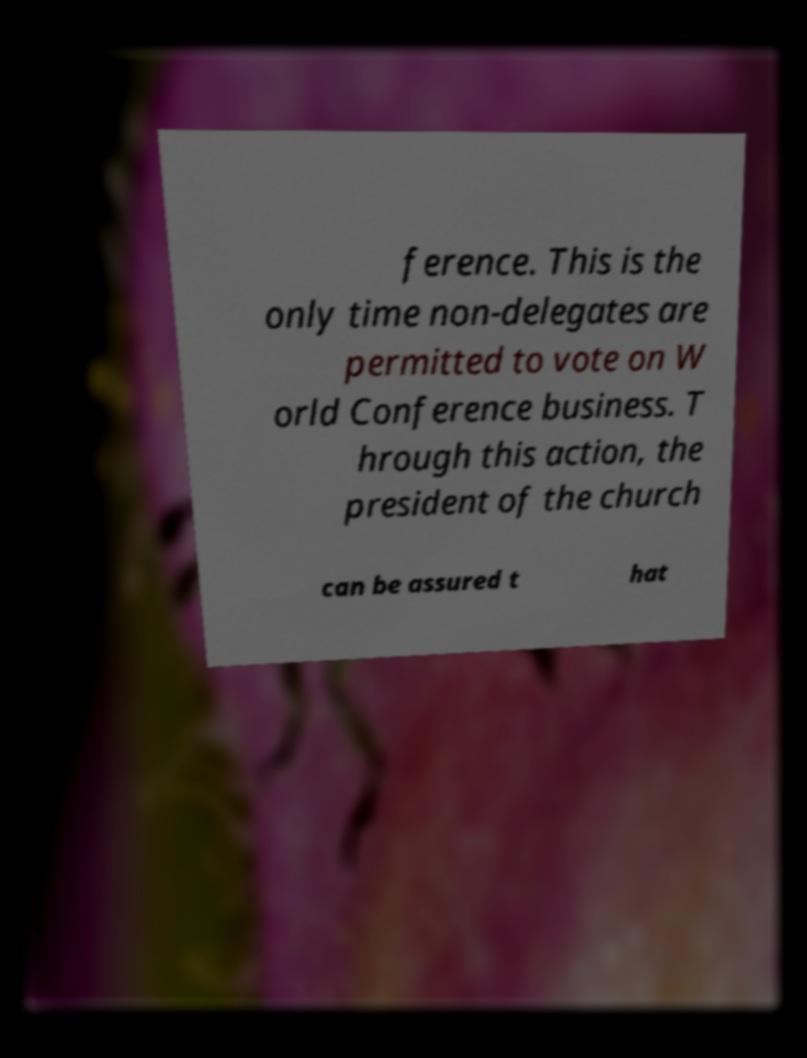I need the written content from this picture converted into text. Can you do that? ference. This is the only time non-delegates are permitted to vote on W orld Conference business. T hrough this action, the president of the church can be assured t hat 